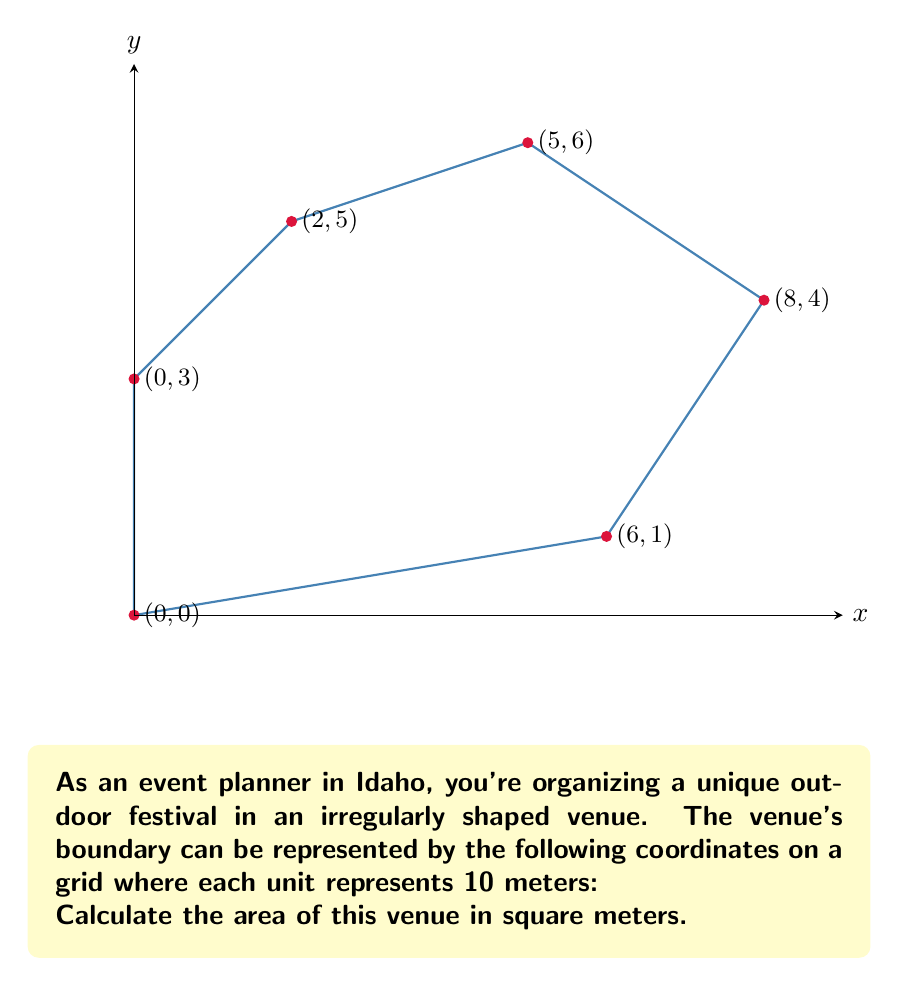Solve this math problem. To calculate the area of this irregular polygon, we can use the Shoelace formula (also known as the surveyor's formula). The formula is:

$$ A = \frac{1}{2}|\sum_{i=1}^{n-1} (x_iy_{i+1} - x_{i+1}y_i) + (x_ny_1 - x_1y_n)| $$

Where $(x_i, y_i)$ are the coordinates of the $i$-th vertex.

Let's apply this formula to our coordinates:

1) First, let's list out our coordinates in order:
   $(0,0)$, $(6,1)$, $(8,4)$, $(5,6)$, $(2,5)$, $(0,3)$

2) Now, let's calculate each term in the sum:
   $0 \cdot 1 - 6 \cdot 0 = 0$
   $6 \cdot 4 - 8 \cdot 1 = 16$
   $8 \cdot 6 - 5 \cdot 4 = 28$
   $5 \cdot 5 - 2 \cdot 6 = 13$
   $2 \cdot 3 - 0 \cdot 5 = 6$
   $0 \cdot 0 - 0 \cdot 3 = 0$

3) Sum these values:
   $0 + 16 + 28 + 13 + 6 + 0 = 63$

4) Multiply by $\frac{1}{2}$:
   $\frac{1}{2} \cdot 63 = 31.5$

5) This gives us the area in square units. Since each unit represents 10 meters, we need to multiply by $10^2 = 100$ to get the area in square meters:
   $31.5 \cdot 100 = 3150$ square meters
Answer: 3150 m² 